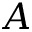<formula> <loc_0><loc_0><loc_500><loc_500>A</formula> 